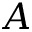<formula> <loc_0><loc_0><loc_500><loc_500>A</formula> 